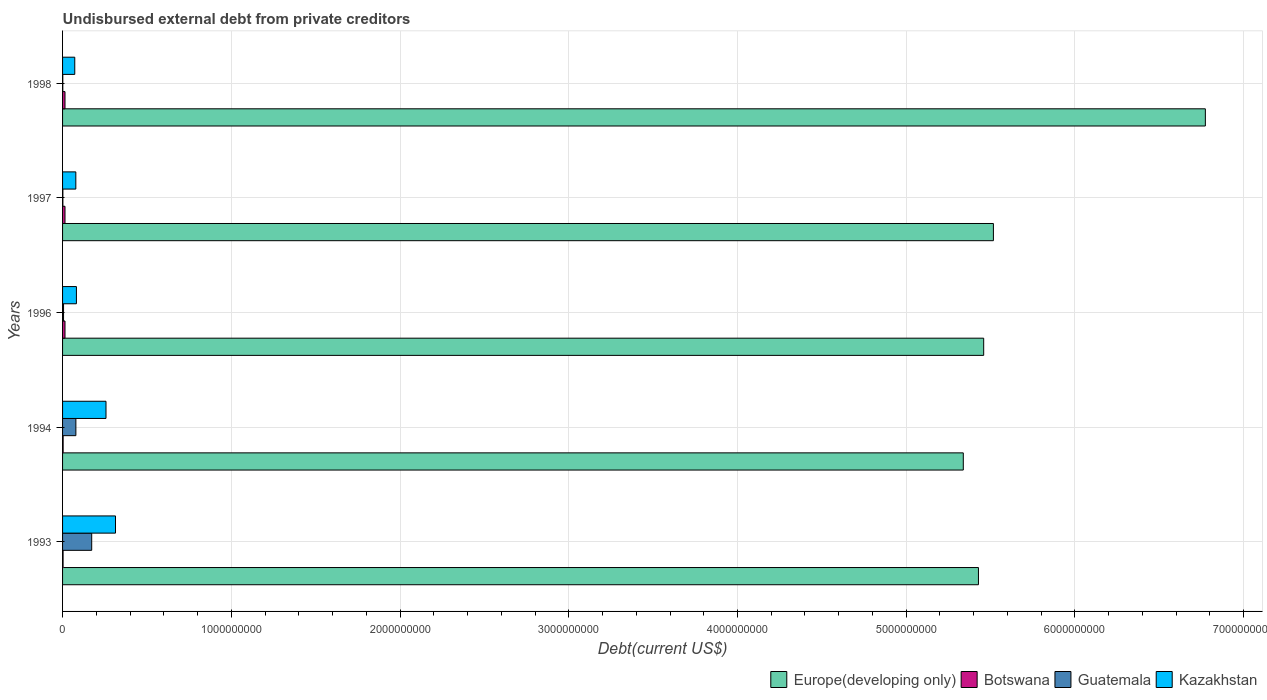How many different coloured bars are there?
Your answer should be compact. 4. How many bars are there on the 3rd tick from the top?
Offer a terse response. 4. How many bars are there on the 4th tick from the bottom?
Offer a terse response. 4. In how many cases, is the number of bars for a given year not equal to the number of legend labels?
Your response must be concise. 0. What is the total debt in Botswana in 1997?
Provide a succinct answer. 1.44e+07. Across all years, what is the maximum total debt in Europe(developing only)?
Keep it short and to the point. 6.77e+09. Across all years, what is the minimum total debt in Guatemala?
Offer a very short reply. 1.36e+06. In which year was the total debt in Botswana maximum?
Provide a short and direct response. 1996. What is the total total debt in Europe(developing only) in the graph?
Your answer should be very brief. 2.85e+1. What is the difference between the total debt in Guatemala in 1996 and that in 1998?
Provide a short and direct response. 4.50e+06. What is the difference between the total debt in Europe(developing only) in 1993 and the total debt in Kazakhstan in 1997?
Give a very brief answer. 5.35e+09. What is the average total debt in Europe(developing only) per year?
Offer a terse response. 5.70e+09. In the year 1997, what is the difference between the total debt in Guatemala and total debt in Botswana?
Offer a very short reply. -1.26e+07. What is the ratio of the total debt in Kazakhstan in 1994 to that in 1996?
Your response must be concise. 3.13. Is the difference between the total debt in Guatemala in 1993 and 1997 greater than the difference between the total debt in Botswana in 1993 and 1997?
Ensure brevity in your answer.  Yes. What is the difference between the highest and the second highest total debt in Guatemala?
Your response must be concise. 9.38e+07. What is the difference between the highest and the lowest total debt in Botswana?
Your answer should be compact. 1.14e+07. In how many years, is the total debt in Kazakhstan greater than the average total debt in Kazakhstan taken over all years?
Make the answer very short. 2. Is it the case that in every year, the sum of the total debt in Botswana and total debt in Europe(developing only) is greater than the sum of total debt in Guatemala and total debt in Kazakhstan?
Your answer should be compact. Yes. What does the 1st bar from the top in 1994 represents?
Your response must be concise. Kazakhstan. What does the 3rd bar from the bottom in 1996 represents?
Provide a short and direct response. Guatemala. Is it the case that in every year, the sum of the total debt in Guatemala and total debt in Europe(developing only) is greater than the total debt in Kazakhstan?
Keep it short and to the point. Yes. Are all the bars in the graph horizontal?
Give a very brief answer. Yes. What is the difference between two consecutive major ticks on the X-axis?
Provide a succinct answer. 1.00e+09. Are the values on the major ticks of X-axis written in scientific E-notation?
Keep it short and to the point. No. Does the graph contain any zero values?
Provide a short and direct response. No. Where does the legend appear in the graph?
Your answer should be compact. Bottom right. What is the title of the graph?
Your answer should be very brief. Undisbursed external debt from private creditors. What is the label or title of the X-axis?
Your answer should be compact. Debt(current US$). What is the label or title of the Y-axis?
Your answer should be very brief. Years. What is the Debt(current US$) of Europe(developing only) in 1993?
Your response must be concise. 5.43e+09. What is the Debt(current US$) in Botswana in 1993?
Ensure brevity in your answer.  3.08e+06. What is the Debt(current US$) of Guatemala in 1993?
Your response must be concise. 1.73e+08. What is the Debt(current US$) of Kazakhstan in 1993?
Your answer should be very brief. 3.14e+08. What is the Debt(current US$) in Europe(developing only) in 1994?
Make the answer very short. 5.34e+09. What is the Debt(current US$) in Botswana in 1994?
Your answer should be very brief. 3.39e+06. What is the Debt(current US$) of Guatemala in 1994?
Provide a succinct answer. 7.89e+07. What is the Debt(current US$) of Kazakhstan in 1994?
Give a very brief answer. 2.57e+08. What is the Debt(current US$) of Europe(developing only) in 1996?
Keep it short and to the point. 5.46e+09. What is the Debt(current US$) of Botswana in 1996?
Ensure brevity in your answer.  1.44e+07. What is the Debt(current US$) of Guatemala in 1996?
Offer a very short reply. 5.85e+06. What is the Debt(current US$) in Kazakhstan in 1996?
Give a very brief answer. 8.22e+07. What is the Debt(current US$) in Europe(developing only) in 1997?
Keep it short and to the point. 5.52e+09. What is the Debt(current US$) in Botswana in 1997?
Keep it short and to the point. 1.44e+07. What is the Debt(current US$) in Guatemala in 1997?
Keep it short and to the point. 1.84e+06. What is the Debt(current US$) of Kazakhstan in 1997?
Provide a succinct answer. 7.86e+07. What is the Debt(current US$) of Europe(developing only) in 1998?
Provide a short and direct response. 6.77e+09. What is the Debt(current US$) of Botswana in 1998?
Give a very brief answer. 1.44e+07. What is the Debt(current US$) in Guatemala in 1998?
Your answer should be compact. 1.36e+06. What is the Debt(current US$) of Kazakhstan in 1998?
Your answer should be very brief. 7.23e+07. Across all years, what is the maximum Debt(current US$) of Europe(developing only)?
Give a very brief answer. 6.77e+09. Across all years, what is the maximum Debt(current US$) of Botswana?
Offer a very short reply. 1.44e+07. Across all years, what is the maximum Debt(current US$) in Guatemala?
Ensure brevity in your answer.  1.73e+08. Across all years, what is the maximum Debt(current US$) of Kazakhstan?
Make the answer very short. 3.14e+08. Across all years, what is the minimum Debt(current US$) in Europe(developing only)?
Offer a very short reply. 5.34e+09. Across all years, what is the minimum Debt(current US$) in Botswana?
Make the answer very short. 3.08e+06. Across all years, what is the minimum Debt(current US$) in Guatemala?
Your response must be concise. 1.36e+06. Across all years, what is the minimum Debt(current US$) in Kazakhstan?
Keep it short and to the point. 7.23e+07. What is the total Debt(current US$) in Europe(developing only) in the graph?
Offer a terse response. 2.85e+1. What is the total Debt(current US$) of Botswana in the graph?
Provide a succinct answer. 4.98e+07. What is the total Debt(current US$) in Guatemala in the graph?
Your answer should be very brief. 2.61e+08. What is the total Debt(current US$) in Kazakhstan in the graph?
Offer a very short reply. 8.04e+08. What is the difference between the Debt(current US$) in Europe(developing only) in 1993 and that in 1994?
Your answer should be compact. 8.98e+07. What is the difference between the Debt(current US$) of Botswana in 1993 and that in 1994?
Provide a short and direct response. -3.10e+05. What is the difference between the Debt(current US$) in Guatemala in 1993 and that in 1994?
Provide a short and direct response. 9.38e+07. What is the difference between the Debt(current US$) in Kazakhstan in 1993 and that in 1994?
Give a very brief answer. 5.63e+07. What is the difference between the Debt(current US$) in Europe(developing only) in 1993 and that in 1996?
Provide a succinct answer. -3.10e+07. What is the difference between the Debt(current US$) in Botswana in 1993 and that in 1996?
Your answer should be very brief. -1.14e+07. What is the difference between the Debt(current US$) in Guatemala in 1993 and that in 1996?
Provide a short and direct response. 1.67e+08. What is the difference between the Debt(current US$) of Kazakhstan in 1993 and that in 1996?
Your answer should be compact. 2.32e+08. What is the difference between the Debt(current US$) in Europe(developing only) in 1993 and that in 1997?
Offer a very short reply. -8.87e+07. What is the difference between the Debt(current US$) of Botswana in 1993 and that in 1997?
Your answer should be very brief. -1.14e+07. What is the difference between the Debt(current US$) of Guatemala in 1993 and that in 1997?
Provide a succinct answer. 1.71e+08. What is the difference between the Debt(current US$) in Kazakhstan in 1993 and that in 1997?
Keep it short and to the point. 2.35e+08. What is the difference between the Debt(current US$) in Europe(developing only) in 1993 and that in 1998?
Your answer should be very brief. -1.34e+09. What is the difference between the Debt(current US$) of Botswana in 1993 and that in 1998?
Offer a terse response. -1.14e+07. What is the difference between the Debt(current US$) of Guatemala in 1993 and that in 1998?
Provide a short and direct response. 1.71e+08. What is the difference between the Debt(current US$) in Kazakhstan in 1993 and that in 1998?
Ensure brevity in your answer.  2.41e+08. What is the difference between the Debt(current US$) of Europe(developing only) in 1994 and that in 1996?
Offer a very short reply. -1.21e+08. What is the difference between the Debt(current US$) of Botswana in 1994 and that in 1996?
Your answer should be compact. -1.10e+07. What is the difference between the Debt(current US$) in Guatemala in 1994 and that in 1996?
Your answer should be very brief. 7.30e+07. What is the difference between the Debt(current US$) of Kazakhstan in 1994 and that in 1996?
Keep it short and to the point. 1.75e+08. What is the difference between the Debt(current US$) of Europe(developing only) in 1994 and that in 1997?
Make the answer very short. -1.78e+08. What is the difference between the Debt(current US$) in Botswana in 1994 and that in 1997?
Your response must be concise. -1.10e+07. What is the difference between the Debt(current US$) of Guatemala in 1994 and that in 1997?
Your response must be concise. 7.70e+07. What is the difference between the Debt(current US$) of Kazakhstan in 1994 and that in 1997?
Your answer should be very brief. 1.79e+08. What is the difference between the Debt(current US$) in Europe(developing only) in 1994 and that in 1998?
Your answer should be very brief. -1.43e+09. What is the difference between the Debt(current US$) in Botswana in 1994 and that in 1998?
Make the answer very short. -1.10e+07. What is the difference between the Debt(current US$) in Guatemala in 1994 and that in 1998?
Your answer should be very brief. 7.75e+07. What is the difference between the Debt(current US$) in Kazakhstan in 1994 and that in 1998?
Ensure brevity in your answer.  1.85e+08. What is the difference between the Debt(current US$) of Europe(developing only) in 1996 and that in 1997?
Provide a succinct answer. -5.77e+07. What is the difference between the Debt(current US$) of Botswana in 1996 and that in 1997?
Your answer should be compact. 0. What is the difference between the Debt(current US$) in Guatemala in 1996 and that in 1997?
Your response must be concise. 4.01e+06. What is the difference between the Debt(current US$) of Kazakhstan in 1996 and that in 1997?
Keep it short and to the point. 3.53e+06. What is the difference between the Debt(current US$) of Europe(developing only) in 1996 and that in 1998?
Your answer should be very brief. -1.31e+09. What is the difference between the Debt(current US$) in Guatemala in 1996 and that in 1998?
Give a very brief answer. 4.50e+06. What is the difference between the Debt(current US$) in Kazakhstan in 1996 and that in 1998?
Provide a succinct answer. 9.86e+06. What is the difference between the Debt(current US$) of Europe(developing only) in 1997 and that in 1998?
Ensure brevity in your answer.  -1.26e+09. What is the difference between the Debt(current US$) of Guatemala in 1997 and that in 1998?
Your answer should be very brief. 4.88e+05. What is the difference between the Debt(current US$) in Kazakhstan in 1997 and that in 1998?
Provide a succinct answer. 6.33e+06. What is the difference between the Debt(current US$) of Europe(developing only) in 1993 and the Debt(current US$) of Botswana in 1994?
Keep it short and to the point. 5.42e+09. What is the difference between the Debt(current US$) of Europe(developing only) in 1993 and the Debt(current US$) of Guatemala in 1994?
Offer a terse response. 5.35e+09. What is the difference between the Debt(current US$) in Europe(developing only) in 1993 and the Debt(current US$) in Kazakhstan in 1994?
Offer a very short reply. 5.17e+09. What is the difference between the Debt(current US$) in Botswana in 1993 and the Debt(current US$) in Guatemala in 1994?
Provide a succinct answer. -7.58e+07. What is the difference between the Debt(current US$) in Botswana in 1993 and the Debt(current US$) in Kazakhstan in 1994?
Your answer should be compact. -2.54e+08. What is the difference between the Debt(current US$) of Guatemala in 1993 and the Debt(current US$) of Kazakhstan in 1994?
Offer a very short reply. -8.48e+07. What is the difference between the Debt(current US$) of Europe(developing only) in 1993 and the Debt(current US$) of Botswana in 1996?
Make the answer very short. 5.41e+09. What is the difference between the Debt(current US$) in Europe(developing only) in 1993 and the Debt(current US$) in Guatemala in 1996?
Your response must be concise. 5.42e+09. What is the difference between the Debt(current US$) in Europe(developing only) in 1993 and the Debt(current US$) in Kazakhstan in 1996?
Offer a terse response. 5.35e+09. What is the difference between the Debt(current US$) in Botswana in 1993 and the Debt(current US$) in Guatemala in 1996?
Your answer should be very brief. -2.77e+06. What is the difference between the Debt(current US$) of Botswana in 1993 and the Debt(current US$) of Kazakhstan in 1996?
Ensure brevity in your answer.  -7.91e+07. What is the difference between the Debt(current US$) in Guatemala in 1993 and the Debt(current US$) in Kazakhstan in 1996?
Your response must be concise. 9.05e+07. What is the difference between the Debt(current US$) of Europe(developing only) in 1993 and the Debt(current US$) of Botswana in 1997?
Offer a terse response. 5.41e+09. What is the difference between the Debt(current US$) in Europe(developing only) in 1993 and the Debt(current US$) in Guatemala in 1997?
Your answer should be compact. 5.43e+09. What is the difference between the Debt(current US$) in Europe(developing only) in 1993 and the Debt(current US$) in Kazakhstan in 1997?
Keep it short and to the point. 5.35e+09. What is the difference between the Debt(current US$) in Botswana in 1993 and the Debt(current US$) in Guatemala in 1997?
Make the answer very short. 1.24e+06. What is the difference between the Debt(current US$) in Botswana in 1993 and the Debt(current US$) in Kazakhstan in 1997?
Give a very brief answer. -7.56e+07. What is the difference between the Debt(current US$) of Guatemala in 1993 and the Debt(current US$) of Kazakhstan in 1997?
Your answer should be very brief. 9.40e+07. What is the difference between the Debt(current US$) in Europe(developing only) in 1993 and the Debt(current US$) in Botswana in 1998?
Your answer should be very brief. 5.41e+09. What is the difference between the Debt(current US$) in Europe(developing only) in 1993 and the Debt(current US$) in Guatemala in 1998?
Give a very brief answer. 5.43e+09. What is the difference between the Debt(current US$) of Europe(developing only) in 1993 and the Debt(current US$) of Kazakhstan in 1998?
Your answer should be very brief. 5.36e+09. What is the difference between the Debt(current US$) in Botswana in 1993 and the Debt(current US$) in Guatemala in 1998?
Your response must be concise. 1.72e+06. What is the difference between the Debt(current US$) of Botswana in 1993 and the Debt(current US$) of Kazakhstan in 1998?
Your answer should be compact. -6.92e+07. What is the difference between the Debt(current US$) in Guatemala in 1993 and the Debt(current US$) in Kazakhstan in 1998?
Your answer should be compact. 1.00e+08. What is the difference between the Debt(current US$) of Europe(developing only) in 1994 and the Debt(current US$) of Botswana in 1996?
Keep it short and to the point. 5.32e+09. What is the difference between the Debt(current US$) of Europe(developing only) in 1994 and the Debt(current US$) of Guatemala in 1996?
Keep it short and to the point. 5.33e+09. What is the difference between the Debt(current US$) of Europe(developing only) in 1994 and the Debt(current US$) of Kazakhstan in 1996?
Offer a terse response. 5.26e+09. What is the difference between the Debt(current US$) in Botswana in 1994 and the Debt(current US$) in Guatemala in 1996?
Give a very brief answer. -2.46e+06. What is the difference between the Debt(current US$) in Botswana in 1994 and the Debt(current US$) in Kazakhstan in 1996?
Provide a short and direct response. -7.88e+07. What is the difference between the Debt(current US$) of Guatemala in 1994 and the Debt(current US$) of Kazakhstan in 1996?
Your answer should be very brief. -3.27e+06. What is the difference between the Debt(current US$) of Europe(developing only) in 1994 and the Debt(current US$) of Botswana in 1997?
Provide a succinct answer. 5.32e+09. What is the difference between the Debt(current US$) of Europe(developing only) in 1994 and the Debt(current US$) of Guatemala in 1997?
Provide a succinct answer. 5.34e+09. What is the difference between the Debt(current US$) of Europe(developing only) in 1994 and the Debt(current US$) of Kazakhstan in 1997?
Your answer should be very brief. 5.26e+09. What is the difference between the Debt(current US$) of Botswana in 1994 and the Debt(current US$) of Guatemala in 1997?
Provide a succinct answer. 1.55e+06. What is the difference between the Debt(current US$) of Botswana in 1994 and the Debt(current US$) of Kazakhstan in 1997?
Provide a succinct answer. -7.52e+07. What is the difference between the Debt(current US$) of Guatemala in 1994 and the Debt(current US$) of Kazakhstan in 1997?
Keep it short and to the point. 2.54e+05. What is the difference between the Debt(current US$) of Europe(developing only) in 1994 and the Debt(current US$) of Botswana in 1998?
Keep it short and to the point. 5.32e+09. What is the difference between the Debt(current US$) in Europe(developing only) in 1994 and the Debt(current US$) in Guatemala in 1998?
Provide a short and direct response. 5.34e+09. What is the difference between the Debt(current US$) in Europe(developing only) in 1994 and the Debt(current US$) in Kazakhstan in 1998?
Your answer should be very brief. 5.27e+09. What is the difference between the Debt(current US$) in Botswana in 1994 and the Debt(current US$) in Guatemala in 1998?
Make the answer very short. 2.03e+06. What is the difference between the Debt(current US$) of Botswana in 1994 and the Debt(current US$) of Kazakhstan in 1998?
Keep it short and to the point. -6.89e+07. What is the difference between the Debt(current US$) in Guatemala in 1994 and the Debt(current US$) in Kazakhstan in 1998?
Ensure brevity in your answer.  6.59e+06. What is the difference between the Debt(current US$) of Europe(developing only) in 1996 and the Debt(current US$) of Botswana in 1997?
Your response must be concise. 5.44e+09. What is the difference between the Debt(current US$) of Europe(developing only) in 1996 and the Debt(current US$) of Guatemala in 1997?
Your answer should be compact. 5.46e+09. What is the difference between the Debt(current US$) of Europe(developing only) in 1996 and the Debt(current US$) of Kazakhstan in 1997?
Ensure brevity in your answer.  5.38e+09. What is the difference between the Debt(current US$) of Botswana in 1996 and the Debt(current US$) of Guatemala in 1997?
Give a very brief answer. 1.26e+07. What is the difference between the Debt(current US$) of Botswana in 1996 and the Debt(current US$) of Kazakhstan in 1997?
Ensure brevity in your answer.  -6.42e+07. What is the difference between the Debt(current US$) of Guatemala in 1996 and the Debt(current US$) of Kazakhstan in 1997?
Make the answer very short. -7.28e+07. What is the difference between the Debt(current US$) of Europe(developing only) in 1996 and the Debt(current US$) of Botswana in 1998?
Give a very brief answer. 5.44e+09. What is the difference between the Debt(current US$) in Europe(developing only) in 1996 and the Debt(current US$) in Guatemala in 1998?
Give a very brief answer. 5.46e+09. What is the difference between the Debt(current US$) in Europe(developing only) in 1996 and the Debt(current US$) in Kazakhstan in 1998?
Provide a short and direct response. 5.39e+09. What is the difference between the Debt(current US$) of Botswana in 1996 and the Debt(current US$) of Guatemala in 1998?
Provide a short and direct response. 1.31e+07. What is the difference between the Debt(current US$) of Botswana in 1996 and the Debt(current US$) of Kazakhstan in 1998?
Keep it short and to the point. -5.79e+07. What is the difference between the Debt(current US$) of Guatemala in 1996 and the Debt(current US$) of Kazakhstan in 1998?
Make the answer very short. -6.65e+07. What is the difference between the Debt(current US$) in Europe(developing only) in 1997 and the Debt(current US$) in Botswana in 1998?
Offer a terse response. 5.50e+09. What is the difference between the Debt(current US$) of Europe(developing only) in 1997 and the Debt(current US$) of Guatemala in 1998?
Offer a very short reply. 5.52e+09. What is the difference between the Debt(current US$) of Europe(developing only) in 1997 and the Debt(current US$) of Kazakhstan in 1998?
Your answer should be compact. 5.44e+09. What is the difference between the Debt(current US$) of Botswana in 1997 and the Debt(current US$) of Guatemala in 1998?
Offer a very short reply. 1.31e+07. What is the difference between the Debt(current US$) in Botswana in 1997 and the Debt(current US$) in Kazakhstan in 1998?
Keep it short and to the point. -5.79e+07. What is the difference between the Debt(current US$) of Guatemala in 1997 and the Debt(current US$) of Kazakhstan in 1998?
Keep it short and to the point. -7.05e+07. What is the average Debt(current US$) of Europe(developing only) per year?
Give a very brief answer. 5.70e+09. What is the average Debt(current US$) of Botswana per year?
Provide a succinct answer. 9.95e+06. What is the average Debt(current US$) of Guatemala per year?
Your answer should be compact. 5.21e+07. What is the average Debt(current US$) of Kazakhstan per year?
Provide a succinct answer. 1.61e+08. In the year 1993, what is the difference between the Debt(current US$) in Europe(developing only) and Debt(current US$) in Botswana?
Provide a short and direct response. 5.43e+09. In the year 1993, what is the difference between the Debt(current US$) of Europe(developing only) and Debt(current US$) of Guatemala?
Offer a terse response. 5.26e+09. In the year 1993, what is the difference between the Debt(current US$) in Europe(developing only) and Debt(current US$) in Kazakhstan?
Make the answer very short. 5.11e+09. In the year 1993, what is the difference between the Debt(current US$) in Botswana and Debt(current US$) in Guatemala?
Provide a succinct answer. -1.70e+08. In the year 1993, what is the difference between the Debt(current US$) in Botswana and Debt(current US$) in Kazakhstan?
Provide a short and direct response. -3.11e+08. In the year 1993, what is the difference between the Debt(current US$) in Guatemala and Debt(current US$) in Kazakhstan?
Give a very brief answer. -1.41e+08. In the year 1994, what is the difference between the Debt(current US$) of Europe(developing only) and Debt(current US$) of Botswana?
Keep it short and to the point. 5.33e+09. In the year 1994, what is the difference between the Debt(current US$) in Europe(developing only) and Debt(current US$) in Guatemala?
Provide a succinct answer. 5.26e+09. In the year 1994, what is the difference between the Debt(current US$) of Europe(developing only) and Debt(current US$) of Kazakhstan?
Provide a short and direct response. 5.08e+09. In the year 1994, what is the difference between the Debt(current US$) in Botswana and Debt(current US$) in Guatemala?
Offer a terse response. -7.55e+07. In the year 1994, what is the difference between the Debt(current US$) in Botswana and Debt(current US$) in Kazakhstan?
Make the answer very short. -2.54e+08. In the year 1994, what is the difference between the Debt(current US$) in Guatemala and Debt(current US$) in Kazakhstan?
Keep it short and to the point. -1.79e+08. In the year 1996, what is the difference between the Debt(current US$) of Europe(developing only) and Debt(current US$) of Botswana?
Your answer should be very brief. 5.44e+09. In the year 1996, what is the difference between the Debt(current US$) of Europe(developing only) and Debt(current US$) of Guatemala?
Offer a terse response. 5.45e+09. In the year 1996, what is the difference between the Debt(current US$) of Europe(developing only) and Debt(current US$) of Kazakhstan?
Your answer should be compact. 5.38e+09. In the year 1996, what is the difference between the Debt(current US$) in Botswana and Debt(current US$) in Guatemala?
Make the answer very short. 8.58e+06. In the year 1996, what is the difference between the Debt(current US$) in Botswana and Debt(current US$) in Kazakhstan?
Offer a terse response. -6.77e+07. In the year 1996, what is the difference between the Debt(current US$) in Guatemala and Debt(current US$) in Kazakhstan?
Your answer should be very brief. -7.63e+07. In the year 1997, what is the difference between the Debt(current US$) of Europe(developing only) and Debt(current US$) of Botswana?
Ensure brevity in your answer.  5.50e+09. In the year 1997, what is the difference between the Debt(current US$) in Europe(developing only) and Debt(current US$) in Guatemala?
Provide a short and direct response. 5.51e+09. In the year 1997, what is the difference between the Debt(current US$) of Europe(developing only) and Debt(current US$) of Kazakhstan?
Your response must be concise. 5.44e+09. In the year 1997, what is the difference between the Debt(current US$) of Botswana and Debt(current US$) of Guatemala?
Your answer should be compact. 1.26e+07. In the year 1997, what is the difference between the Debt(current US$) of Botswana and Debt(current US$) of Kazakhstan?
Your answer should be compact. -6.42e+07. In the year 1997, what is the difference between the Debt(current US$) of Guatemala and Debt(current US$) of Kazakhstan?
Provide a succinct answer. -7.68e+07. In the year 1998, what is the difference between the Debt(current US$) in Europe(developing only) and Debt(current US$) in Botswana?
Your answer should be compact. 6.76e+09. In the year 1998, what is the difference between the Debt(current US$) in Europe(developing only) and Debt(current US$) in Guatemala?
Make the answer very short. 6.77e+09. In the year 1998, what is the difference between the Debt(current US$) of Europe(developing only) and Debt(current US$) of Kazakhstan?
Provide a short and direct response. 6.70e+09. In the year 1998, what is the difference between the Debt(current US$) of Botswana and Debt(current US$) of Guatemala?
Offer a very short reply. 1.31e+07. In the year 1998, what is the difference between the Debt(current US$) of Botswana and Debt(current US$) of Kazakhstan?
Ensure brevity in your answer.  -5.79e+07. In the year 1998, what is the difference between the Debt(current US$) of Guatemala and Debt(current US$) of Kazakhstan?
Ensure brevity in your answer.  -7.09e+07. What is the ratio of the Debt(current US$) of Europe(developing only) in 1993 to that in 1994?
Your response must be concise. 1.02. What is the ratio of the Debt(current US$) of Botswana in 1993 to that in 1994?
Provide a short and direct response. 0.91. What is the ratio of the Debt(current US$) in Guatemala in 1993 to that in 1994?
Keep it short and to the point. 2.19. What is the ratio of the Debt(current US$) of Kazakhstan in 1993 to that in 1994?
Your answer should be compact. 1.22. What is the ratio of the Debt(current US$) of Botswana in 1993 to that in 1996?
Make the answer very short. 0.21. What is the ratio of the Debt(current US$) in Guatemala in 1993 to that in 1996?
Provide a short and direct response. 29.51. What is the ratio of the Debt(current US$) in Kazakhstan in 1993 to that in 1996?
Make the answer very short. 3.82. What is the ratio of the Debt(current US$) in Europe(developing only) in 1993 to that in 1997?
Make the answer very short. 0.98. What is the ratio of the Debt(current US$) in Botswana in 1993 to that in 1997?
Your response must be concise. 0.21. What is the ratio of the Debt(current US$) in Guatemala in 1993 to that in 1997?
Your response must be concise. 93.64. What is the ratio of the Debt(current US$) in Kazakhstan in 1993 to that in 1997?
Keep it short and to the point. 3.99. What is the ratio of the Debt(current US$) of Europe(developing only) in 1993 to that in 1998?
Make the answer very short. 0.8. What is the ratio of the Debt(current US$) of Botswana in 1993 to that in 1998?
Your answer should be very brief. 0.21. What is the ratio of the Debt(current US$) of Guatemala in 1993 to that in 1998?
Give a very brief answer. 127.34. What is the ratio of the Debt(current US$) of Kazakhstan in 1993 to that in 1998?
Provide a short and direct response. 4.34. What is the ratio of the Debt(current US$) of Europe(developing only) in 1994 to that in 1996?
Offer a terse response. 0.98. What is the ratio of the Debt(current US$) in Botswana in 1994 to that in 1996?
Provide a short and direct response. 0.23. What is the ratio of the Debt(current US$) in Guatemala in 1994 to that in 1996?
Ensure brevity in your answer.  13.48. What is the ratio of the Debt(current US$) in Kazakhstan in 1994 to that in 1996?
Your answer should be very brief. 3.13. What is the ratio of the Debt(current US$) in Europe(developing only) in 1994 to that in 1997?
Your response must be concise. 0.97. What is the ratio of the Debt(current US$) in Botswana in 1994 to that in 1997?
Keep it short and to the point. 0.23. What is the ratio of the Debt(current US$) in Guatemala in 1994 to that in 1997?
Ensure brevity in your answer.  42.78. What is the ratio of the Debt(current US$) of Kazakhstan in 1994 to that in 1997?
Your response must be concise. 3.27. What is the ratio of the Debt(current US$) of Europe(developing only) in 1994 to that in 1998?
Offer a very short reply. 0.79. What is the ratio of the Debt(current US$) in Botswana in 1994 to that in 1998?
Offer a very short reply. 0.23. What is the ratio of the Debt(current US$) of Guatemala in 1994 to that in 1998?
Offer a terse response. 58.18. What is the ratio of the Debt(current US$) in Kazakhstan in 1994 to that in 1998?
Give a very brief answer. 3.56. What is the ratio of the Debt(current US$) in Botswana in 1996 to that in 1997?
Provide a succinct answer. 1. What is the ratio of the Debt(current US$) of Guatemala in 1996 to that in 1997?
Offer a very short reply. 3.17. What is the ratio of the Debt(current US$) in Kazakhstan in 1996 to that in 1997?
Give a very brief answer. 1.04. What is the ratio of the Debt(current US$) in Europe(developing only) in 1996 to that in 1998?
Your response must be concise. 0.81. What is the ratio of the Debt(current US$) in Botswana in 1996 to that in 1998?
Provide a short and direct response. 1. What is the ratio of the Debt(current US$) of Guatemala in 1996 to that in 1998?
Offer a terse response. 4.31. What is the ratio of the Debt(current US$) of Kazakhstan in 1996 to that in 1998?
Provide a short and direct response. 1.14. What is the ratio of the Debt(current US$) of Europe(developing only) in 1997 to that in 1998?
Offer a terse response. 0.81. What is the ratio of the Debt(current US$) of Botswana in 1997 to that in 1998?
Provide a succinct answer. 1. What is the ratio of the Debt(current US$) of Guatemala in 1997 to that in 1998?
Give a very brief answer. 1.36. What is the ratio of the Debt(current US$) of Kazakhstan in 1997 to that in 1998?
Provide a succinct answer. 1.09. What is the difference between the highest and the second highest Debt(current US$) of Europe(developing only)?
Ensure brevity in your answer.  1.26e+09. What is the difference between the highest and the second highest Debt(current US$) of Guatemala?
Your answer should be compact. 9.38e+07. What is the difference between the highest and the second highest Debt(current US$) of Kazakhstan?
Provide a short and direct response. 5.63e+07. What is the difference between the highest and the lowest Debt(current US$) of Europe(developing only)?
Your answer should be very brief. 1.43e+09. What is the difference between the highest and the lowest Debt(current US$) in Botswana?
Your response must be concise. 1.14e+07. What is the difference between the highest and the lowest Debt(current US$) in Guatemala?
Provide a short and direct response. 1.71e+08. What is the difference between the highest and the lowest Debt(current US$) of Kazakhstan?
Your response must be concise. 2.41e+08. 